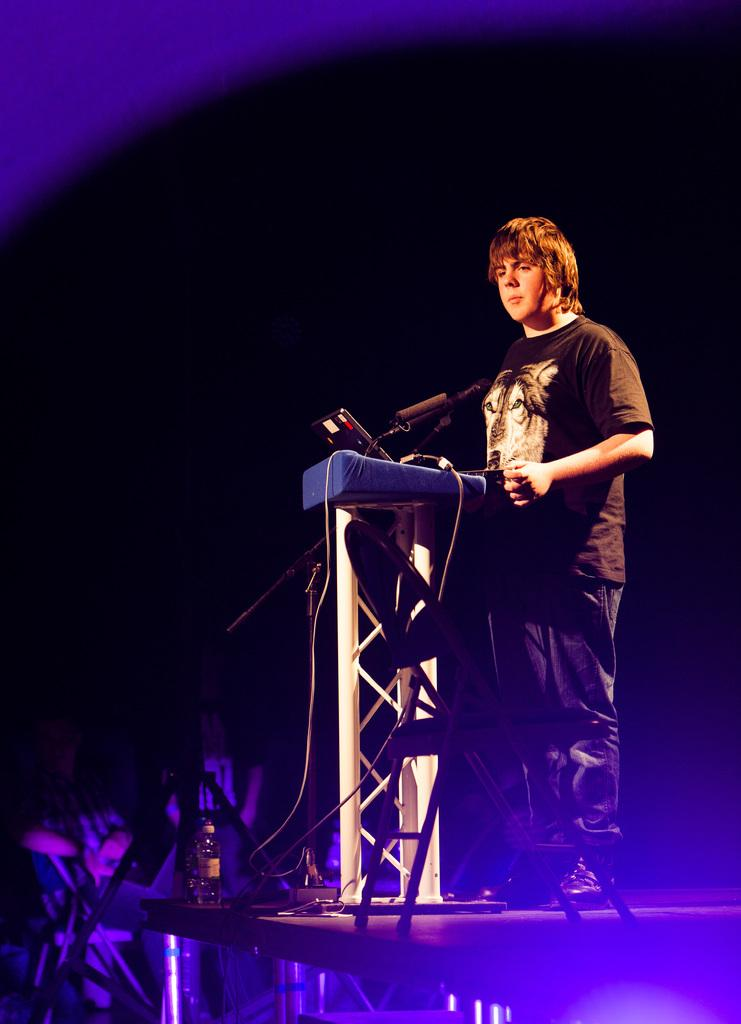What is the person doing on the stage? The person is standing on the stage. What object is on the podium in front of the person? There is a laptop on the podium. What is used for amplifying the person's voice on the stage? There is a mic with a mike stand. What is the other object on the stage? There is a bottle on the stage. How would you describe the lighting conditions in the image? The background of the image is dark. What type of rhythm is the person playing on the stage? There is no indication of any rhythm or musical instrument in the image; the person is simply standing on the stage. 